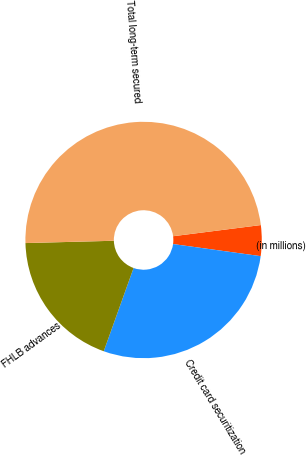Convert chart. <chart><loc_0><loc_0><loc_500><loc_500><pie_chart><fcel>(in millions)<fcel>Credit card securitization<fcel>FHLB advances<fcel>Total long-term secured<nl><fcel>4.2%<fcel>28.29%<fcel>19.11%<fcel>48.4%<nl></chart> 